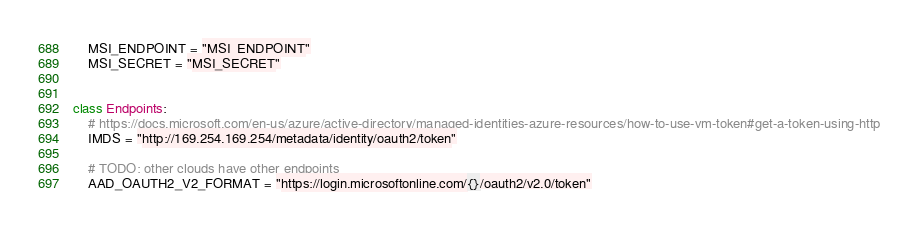<code> <loc_0><loc_0><loc_500><loc_500><_Python_>    MSI_ENDPOINT = "MSI_ENDPOINT"
    MSI_SECRET = "MSI_SECRET"


class Endpoints:
    # https://docs.microsoft.com/en-us/azure/active-directory/managed-identities-azure-resources/how-to-use-vm-token#get-a-token-using-http
    IMDS = "http://169.254.169.254/metadata/identity/oauth2/token"

    # TODO: other clouds have other endpoints
    AAD_OAUTH2_V2_FORMAT = "https://login.microsoftonline.com/{}/oauth2/v2.0/token"
</code> 